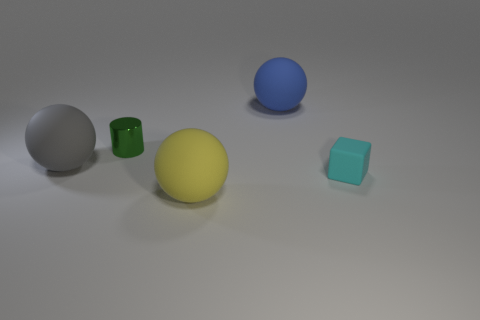What number of other objects are there of the same shape as the big blue object?
Offer a very short reply. 2. Are there any tiny cyan cylinders that have the same material as the large yellow ball?
Your answer should be compact. No. Are the sphere in front of the large gray matte sphere and the big object that is on the right side of the yellow matte ball made of the same material?
Your answer should be very brief. Yes. What number of small brown matte things are there?
Your answer should be very brief. 0. There is a small thing that is behind the small matte thing; what is its shape?
Your answer should be very brief. Cylinder. What number of other objects are the same size as the cyan thing?
Offer a terse response. 1. There is a large thing that is to the right of the yellow sphere; does it have the same shape as the tiny object that is behind the gray sphere?
Your answer should be very brief. No. How many small cyan blocks are in front of the tiny cyan rubber block?
Provide a succinct answer. 0. What color is the large sphere that is behind the metal object?
Your response must be concise. Blue. Is there any other thing of the same color as the small matte block?
Offer a very short reply. No. 